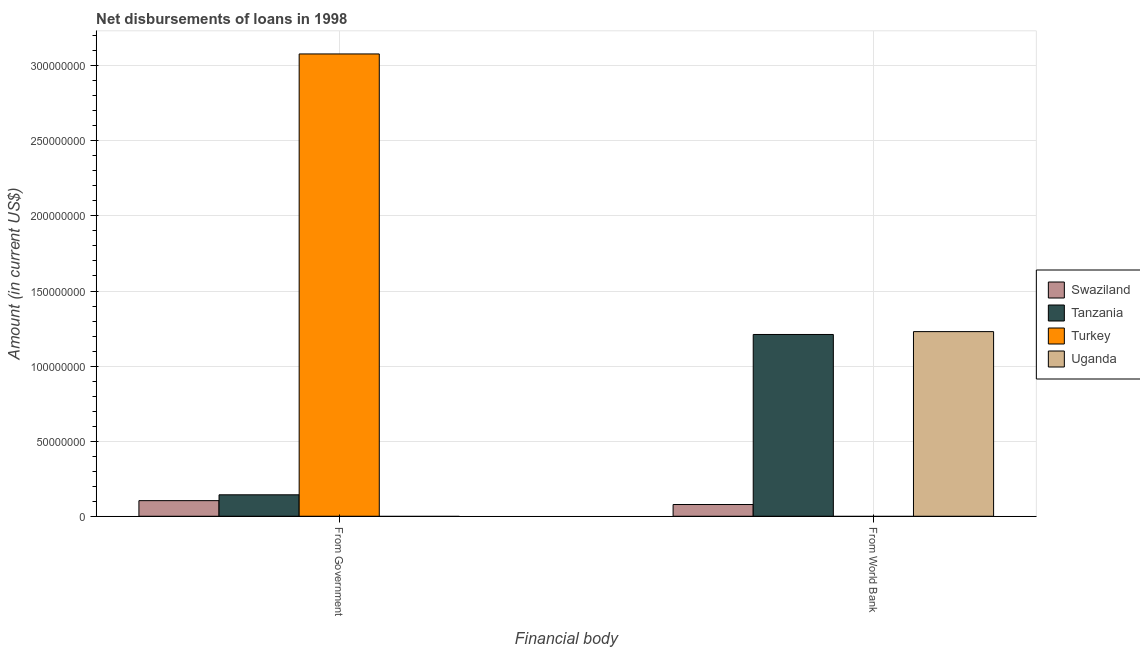Are the number of bars per tick equal to the number of legend labels?
Offer a very short reply. No. What is the label of the 2nd group of bars from the left?
Provide a succinct answer. From World Bank. Across all countries, what is the maximum net disbursements of loan from government?
Your response must be concise. 3.08e+08. What is the total net disbursements of loan from government in the graph?
Make the answer very short. 3.33e+08. What is the difference between the net disbursements of loan from world bank in Swaziland and that in Uganda?
Offer a terse response. -1.15e+08. What is the difference between the net disbursements of loan from world bank in Swaziland and the net disbursements of loan from government in Uganda?
Make the answer very short. 7.82e+06. What is the average net disbursements of loan from government per country?
Offer a terse response. 8.31e+07. What is the difference between the net disbursements of loan from government and net disbursements of loan from world bank in Tanzania?
Give a very brief answer. -1.07e+08. In how many countries, is the net disbursements of loan from world bank greater than 150000000 US$?
Offer a terse response. 0. What is the ratio of the net disbursements of loan from world bank in Swaziland to that in Tanzania?
Provide a succinct answer. 0.06. In how many countries, is the net disbursements of loan from government greater than the average net disbursements of loan from government taken over all countries?
Provide a succinct answer. 1. Does the graph contain grids?
Offer a very short reply. Yes. What is the title of the graph?
Offer a terse response. Net disbursements of loans in 1998. Does "Comoros" appear as one of the legend labels in the graph?
Ensure brevity in your answer.  No. What is the label or title of the X-axis?
Offer a terse response. Financial body. What is the label or title of the Y-axis?
Provide a short and direct response. Amount (in current US$). What is the Amount (in current US$) in Swaziland in From Government?
Your response must be concise. 1.04e+07. What is the Amount (in current US$) of Tanzania in From Government?
Your response must be concise. 1.43e+07. What is the Amount (in current US$) in Turkey in From Government?
Your response must be concise. 3.08e+08. What is the Amount (in current US$) in Uganda in From Government?
Keep it short and to the point. 0. What is the Amount (in current US$) in Swaziland in From World Bank?
Make the answer very short. 7.82e+06. What is the Amount (in current US$) in Tanzania in From World Bank?
Your answer should be very brief. 1.21e+08. What is the Amount (in current US$) in Uganda in From World Bank?
Give a very brief answer. 1.23e+08. Across all Financial body, what is the maximum Amount (in current US$) in Swaziland?
Your response must be concise. 1.04e+07. Across all Financial body, what is the maximum Amount (in current US$) of Tanzania?
Make the answer very short. 1.21e+08. Across all Financial body, what is the maximum Amount (in current US$) of Turkey?
Offer a terse response. 3.08e+08. Across all Financial body, what is the maximum Amount (in current US$) in Uganda?
Provide a succinct answer. 1.23e+08. Across all Financial body, what is the minimum Amount (in current US$) of Swaziland?
Give a very brief answer. 7.82e+06. Across all Financial body, what is the minimum Amount (in current US$) of Tanzania?
Give a very brief answer. 1.43e+07. What is the total Amount (in current US$) in Swaziland in the graph?
Your answer should be very brief. 1.82e+07. What is the total Amount (in current US$) in Tanzania in the graph?
Keep it short and to the point. 1.35e+08. What is the total Amount (in current US$) in Turkey in the graph?
Offer a terse response. 3.08e+08. What is the total Amount (in current US$) in Uganda in the graph?
Your response must be concise. 1.23e+08. What is the difference between the Amount (in current US$) in Swaziland in From Government and that in From World Bank?
Make the answer very short. 2.57e+06. What is the difference between the Amount (in current US$) of Tanzania in From Government and that in From World Bank?
Give a very brief answer. -1.07e+08. What is the difference between the Amount (in current US$) in Swaziland in From Government and the Amount (in current US$) in Tanzania in From World Bank?
Provide a short and direct response. -1.11e+08. What is the difference between the Amount (in current US$) of Swaziland in From Government and the Amount (in current US$) of Uganda in From World Bank?
Give a very brief answer. -1.13e+08. What is the difference between the Amount (in current US$) in Tanzania in From Government and the Amount (in current US$) in Uganda in From World Bank?
Keep it short and to the point. -1.09e+08. What is the difference between the Amount (in current US$) of Turkey in From Government and the Amount (in current US$) of Uganda in From World Bank?
Provide a succinct answer. 1.85e+08. What is the average Amount (in current US$) of Swaziland per Financial body?
Your answer should be compact. 9.10e+06. What is the average Amount (in current US$) of Tanzania per Financial body?
Provide a succinct answer. 6.77e+07. What is the average Amount (in current US$) in Turkey per Financial body?
Offer a very short reply. 1.54e+08. What is the average Amount (in current US$) in Uganda per Financial body?
Make the answer very short. 6.15e+07. What is the difference between the Amount (in current US$) of Swaziland and Amount (in current US$) of Tanzania in From Government?
Provide a short and direct response. -3.89e+06. What is the difference between the Amount (in current US$) in Swaziland and Amount (in current US$) in Turkey in From Government?
Keep it short and to the point. -2.97e+08. What is the difference between the Amount (in current US$) of Tanzania and Amount (in current US$) of Turkey in From Government?
Offer a terse response. -2.94e+08. What is the difference between the Amount (in current US$) of Swaziland and Amount (in current US$) of Tanzania in From World Bank?
Offer a very short reply. -1.13e+08. What is the difference between the Amount (in current US$) in Swaziland and Amount (in current US$) in Uganda in From World Bank?
Provide a succinct answer. -1.15e+08. What is the difference between the Amount (in current US$) of Tanzania and Amount (in current US$) of Uganda in From World Bank?
Provide a succinct answer. -1.90e+06. What is the ratio of the Amount (in current US$) of Swaziland in From Government to that in From World Bank?
Ensure brevity in your answer.  1.33. What is the ratio of the Amount (in current US$) in Tanzania in From Government to that in From World Bank?
Provide a succinct answer. 0.12. What is the difference between the highest and the second highest Amount (in current US$) of Swaziland?
Provide a short and direct response. 2.57e+06. What is the difference between the highest and the second highest Amount (in current US$) in Tanzania?
Give a very brief answer. 1.07e+08. What is the difference between the highest and the lowest Amount (in current US$) of Swaziland?
Give a very brief answer. 2.57e+06. What is the difference between the highest and the lowest Amount (in current US$) of Tanzania?
Your answer should be very brief. 1.07e+08. What is the difference between the highest and the lowest Amount (in current US$) in Turkey?
Your answer should be compact. 3.08e+08. What is the difference between the highest and the lowest Amount (in current US$) of Uganda?
Give a very brief answer. 1.23e+08. 